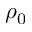Convert formula to latex. <formula><loc_0><loc_0><loc_500><loc_500>\rho _ { 0 }</formula> 